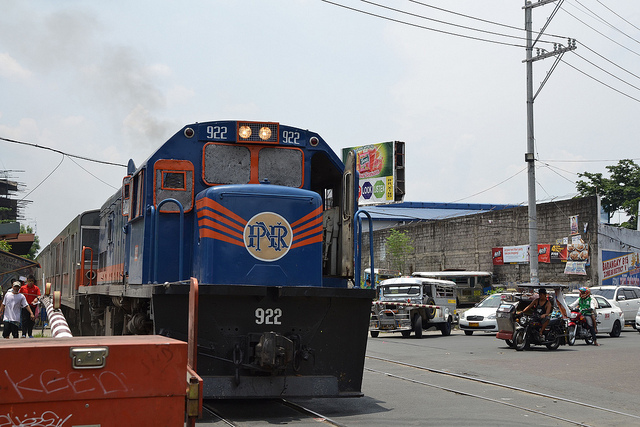Identify the text displayed in this image. 922 922 PR 922 KEEn 